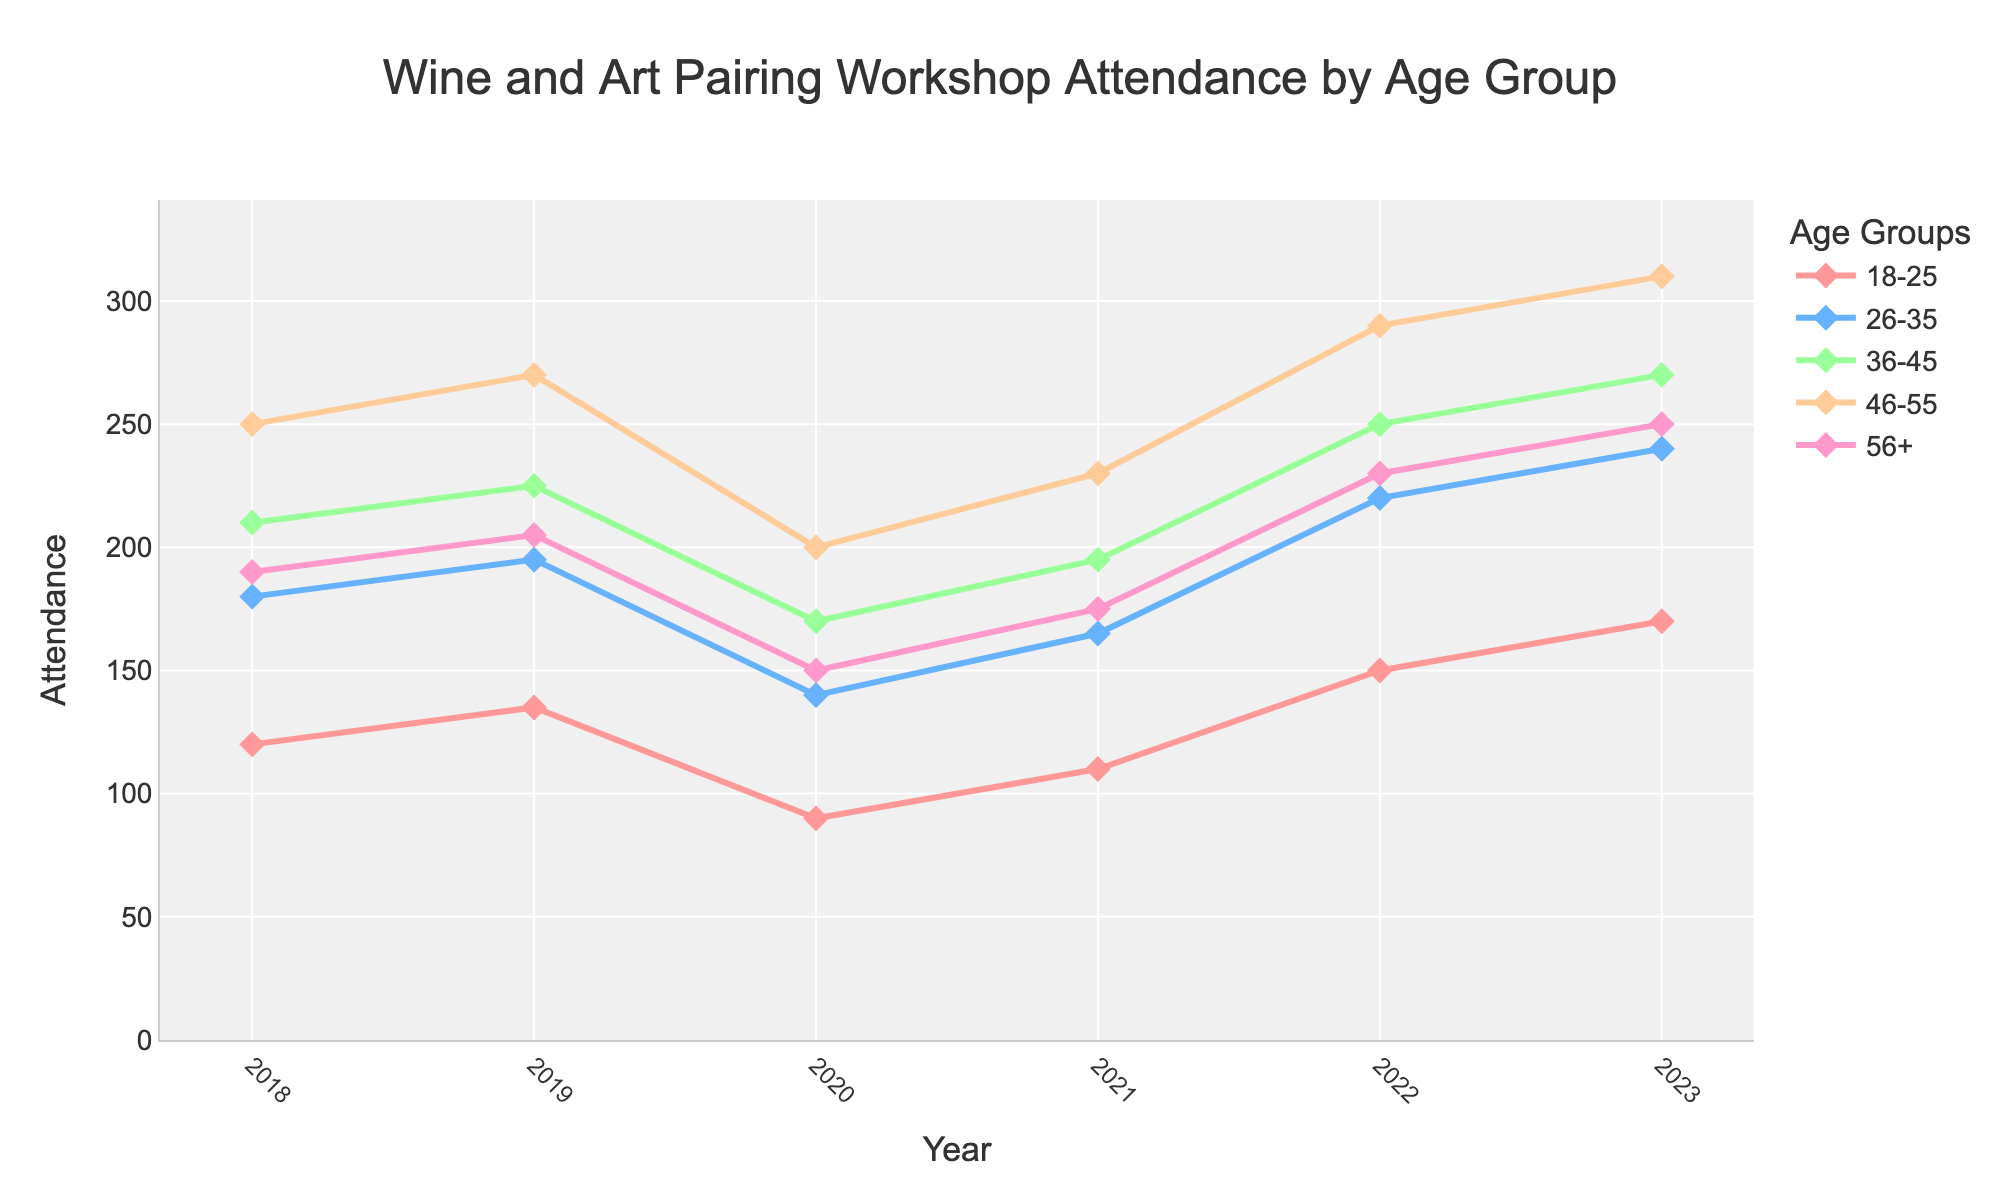Which age group had the highest attendance in 2023? Look at the values for each age group in 2023 and find the largest number. The values are 170 (18-25), 240 (26-35), 270 (36-45), 310 (46-55), 250 (56+). The highest number is 310.
Answer: 46-55 How did the attendance for the 18-25 age group change from 2020 to 2022? Subtract the 2020 value from the 2022 value for the 18-25 age group. The values are 150 (2022) and 90 (2020). So, 150 - 90 = 60.
Answer: Increased by 60 Which year saw a drop in attendance across all age groups? Compare the attendance values for each year and look for the year where the attendance dropped consistently across all age groups. In 2020, all values decreased compared to 2019: 135 to 90, 195 to 140, 225 to 170, 270 to 200, 205 to 150.
Answer: 2020 What is the total attendance across all age groups in 2021? Sum the attendance values for all age groups in the year 2021. The values are 110 (18-25), 165 (26-35), 195 (36-45), 230 (46-55), 175 (56+). So, 110 + 165 + 195 + 230 + 175 = 875.
Answer: 875 Which age group showed the most significant change in attendance between 2018 and 2023? Subtract the 2018 attendance from the 2023 attendance for each age group and find the largest difference. The differences are: 
170 - 120 = 50 (18-25), 
240 - 180 = 60 (26-35), 
270 - 210 = 60 (36-45), 
310 - 250 = 60 (46-55), 
250 - 190 = 60 (56+). 
All age groups except 18-25 had the same largest increase of 60. So, the 18-25 group had the smallest significant change.
Answer: 26-35, 36-45, 46-55, 56+ Which age group had similar attendance trends over the five years? Visually compare the line trends of each age group over the five years. The age groups 26-35, 46-55, and 56+ show similar upward trends with slight dips in 2020 and a consistent increase afterward.
Answer: 26-35, 46-55, 56+ What was the average attendance for the age group 36-45 over the 5 years? Sum the attendance values for 36-45 over the five years and divide by the number of years. The values are 210 (2018), 225 (2019), 170 (2020), 195 (2021), 250 (2022), 270 (2023). Sum: 210 + 225 + 170 + 195 + 250 + 270 = 1320. Divide by 6: 1320 / 6 = 220.
Answer: 220 How does the attendance trend for the age group 46-55 compare to that of the age group 18-25 between 2018 and 2023? Look at the line trends for both age groups between 2018 and 2023. The 46-55 age group shows a consistent increase with one dip in 2020, whereas the 18-25 age group had more fluctuations and a smaller increase overall.
Answer: 46-55 shows a more consistent increase, while 18-25 fluctuated more In which year did the 26-35 age group see the highest growth rate compared to the previous year? Calculate the growth rates by dividing the change in attendance by the previous year's attendance, then find the highest rate. 
2019: (195 - 180) / 180 = 0.0833, 
2020: (140 - 195) / 195 = -0.2821, 
2021: (165 - 140) / 140 = 0.1786, 
2022: (220 - 165) / 165 = 0.3333, 
2023: (240 - 220) / 220 = 0.0909. 
The highest rate is in 2022.
Answer: 2022 